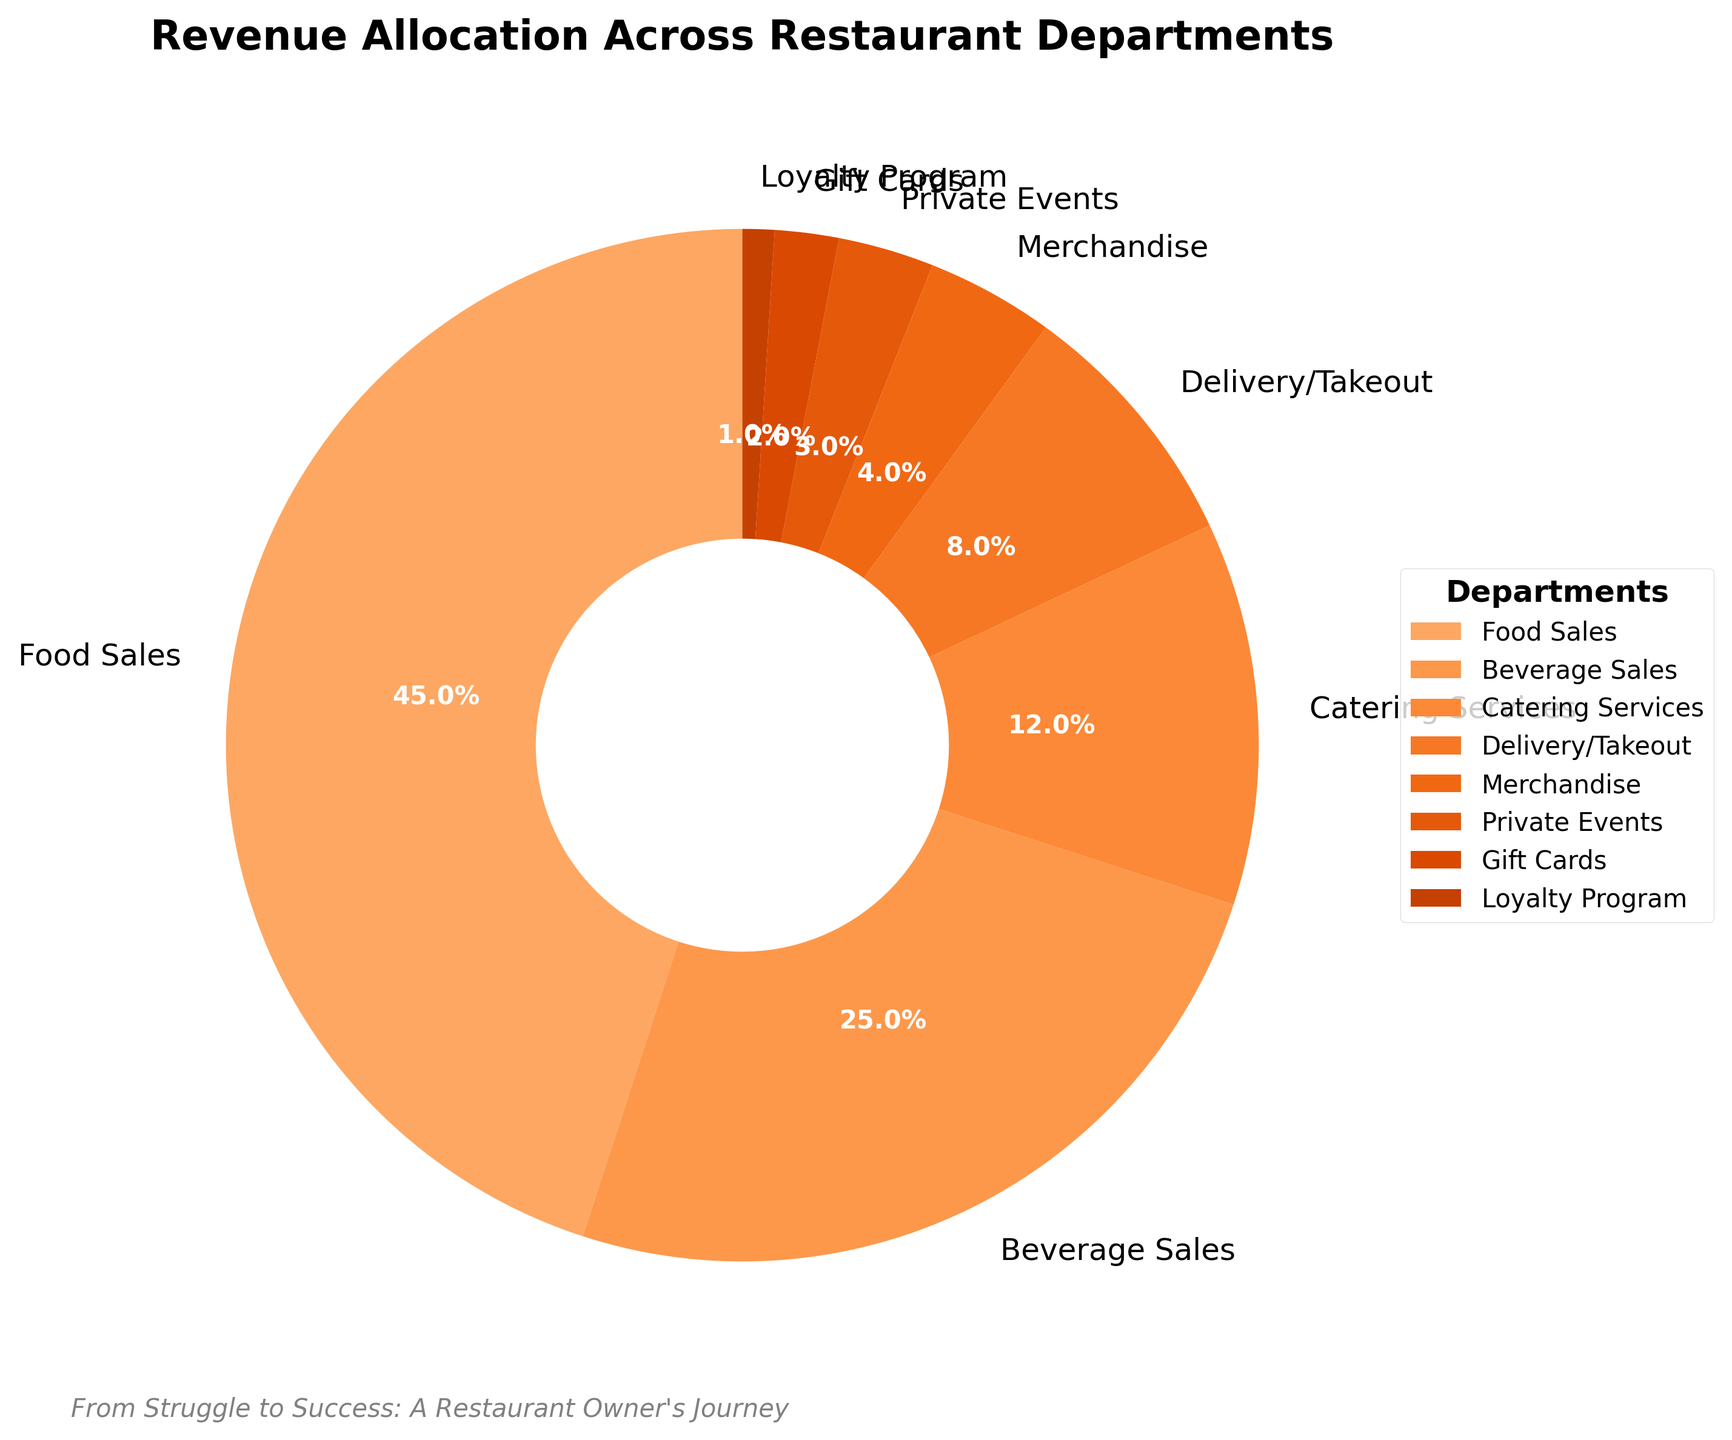What percentage of revenue comes from Food Sales and Beverage Sales combined? To find the combined percentage of revenue from Food Sales and Beverage Sales, add the percentages of both departments: 45% (Food Sales) + 25% (Beverage Sales) = 70%
Answer: 70% Which department contributes the least to the total revenue? The department with the smallest percentage on the pie chart represents the least contribution to total revenue. From the chart, the Loyalty Program has the smallest segment at 1%.
Answer: Loyalty Program How much more revenue does Catering Services generate compared to Delivery/Takeout? Subtract the percentage of Delivery/Takeout (8%) from the percentage of Catering Services (12%): 12% - 8% = 4%
Answer: 4% If you combine the revenue from Merchandise, Private Events, Gift Cards, and the Loyalty Program, what is the total percentage? Add the percentages for Merchandise (4%), Private Events (3%), Gift Cards (2%), and the Loyalty Program (1%): 4% + 3% + 2% + 1% = 10%
Answer: 10% How does the revenue from Private Events compare to that from Merchandise? Compare the percentages of Private Events (3%) and Merchandise (4%). Merchandise generates 1% more revenue than Private Events: 4% - 3% = 1%
Answer: Merchandise generates 1% more What percentage of revenue do departments other than Food Sales and Beverage Sales contribute? Subtract the combined percentage of Food Sales and Beverage Sales (45% + 25% = 70%) from 100% to find the revenue percentage of the other departments: 100% - 70% = 30%
Answer: 30% Which department generates twice the revenue of Gift Cards? Identify the department with 2% revenue (Gift Cards), and find the department with 4% revenue. The chart indicates that Merchandise generates twice the revenue of Gift Cards: 4% / 2% = 2%
Answer: Merchandise What is the ratio of revenue generated from Food Sales to that from the Loyalty Program? Divide the percentage of Food Sales (45%) by the percentage of the Loyalty Program (1%) to find the ratio: 45 / 1 = 45:1
Answer: 45:1 Is the revenue from Beverage Sales greater than the combined revenue from Catering Services and Delivery/Takeout? Add the percentages of Catering Services (12%) and Delivery/Takeout (8%): 12% + 8% = 20%. Compare with Beverage Sales at 25%. Beverage Sales (25%) is greater than 20%.
Answer: Yes, greater Explain the significance of the text “From Struggle to Success: A Restaurant Owner's Journey” on the plot. The text "From Struggle to Success: A Restaurant Owner's Journey" provides a personal narrative and context, highlighting the journey of the restaurant owner from being a refugee to achieving success in the restaurant industry.
Answer: Highlights personal success journey 